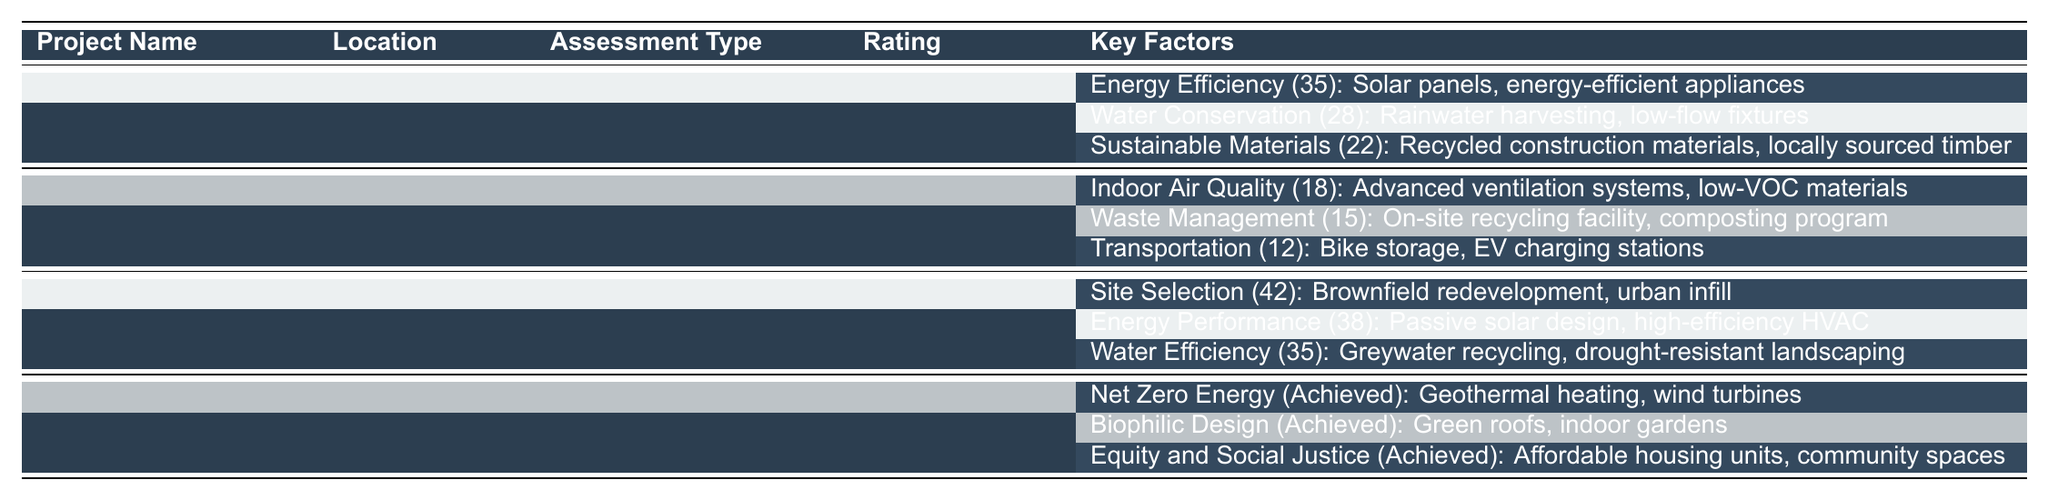What is the rating for the Greenwood Heights project? According to the table, the rating for the Greenwood Heights project is stated explicitly in the "Rating" column, which shows "Gold" for this project.
Answer: Gold Which project has the highest score in Energy Efficiency? The table lists three key factors for each project. By examining the details under "Key Factors," we see that the input for Energy Efficiency at Greenwood Heights has a score of 35, which is the highest compared to the others.
Answer: Greenwood Heights Does the Riverside Towers project have a waste management program? The table indicates that Riverside Towers has a Key Factor listed under "Waste Management," detailing an on-site recycling facility and a composting program, confirming the presence of a waste management program.
Answer: Yes What is the total score for Sustainable Materials across all projects? The scores for Sustainable Materials from the relevant projects are: 22 (Greenwood Heights) + 0 (Riverside Towers) + 0 (Sunset Plaza) + 0 (Harborview Residences). Adding these together yields a total of 22 for Sustainable Materials.
Answer: 22 Which project has the lowest score in Indoor Air Quality? The Riverside Towers project has a score of 18 in Indoor Air Quality, which is the only entry for this category across all projects, making it the lowest in this aspect.
Answer: 18 How many projects achieved a score indicating "Achieved" under their Key Factors? Analyzing the table, Harborview Residences has three Key Factors marked as "Achieved." In contrast, the other projects do not have any achieved scores listed. Thus, only one project achieved this status.
Answer: 1 What is the average score for Water Efficiency across all assessed projects? The Water Efficiency scores are as follows: 0 (Greenwood Heights) + 35 (Sunset Plaza) + 0 (Riverside Towers) + 0 (Harborview Residences). The average would be (0 + 35 + 0 + 0) / 4 = 8.75.
Answer: 8.75 Which assessment type has the most locations listed? The assessment types and their corresponding locations are: LEED Certification (Portland), BREEAM (Chicago), Green Globes (Los Angeles), and Living Building Challenge (Seattle). Each assessment type is associated with exactly one location, meaning no single type has more than one.
Answer: None Which project's rating is classified as "Excellent"? The table explicitly lists Riverside Towers' rating as "Excellent." There are no other projects with this designation.
Answer: Riverside Towers Is there any project that mentions biophilic design as a key factor? The table indicates that Harborview Residences includes "Biophilic Design" as an achieved key factor, thus confirming its presence in this project.
Answer: Yes 